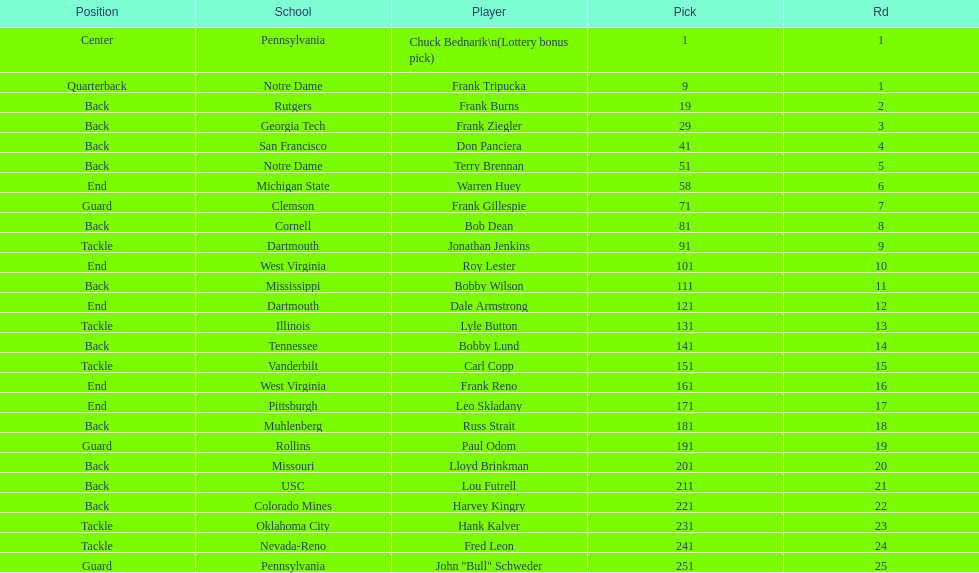What was the position that most of the players had? Back. 